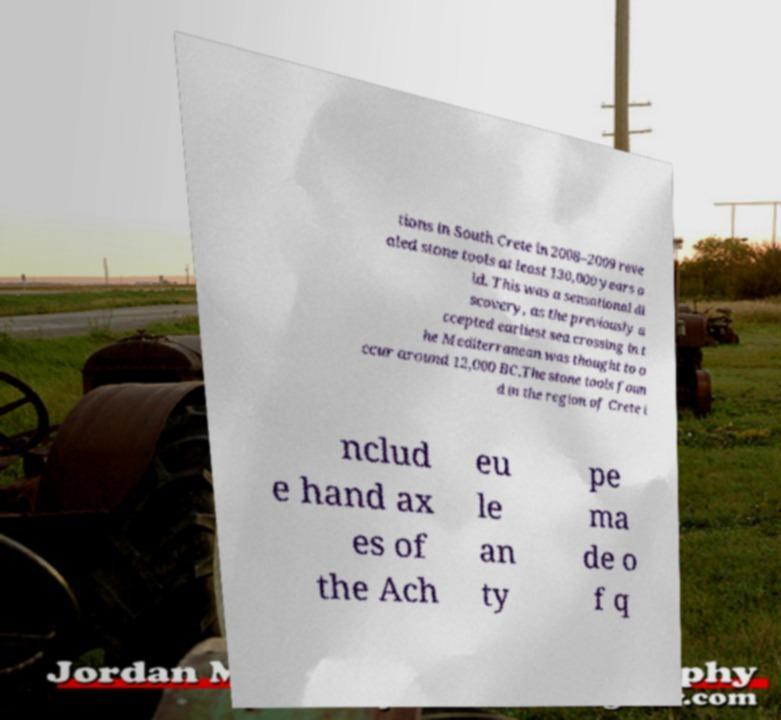Could you extract and type out the text from this image? tions in South Crete in 2008–2009 reve aled stone tools at least 130,000 years o ld. This was a sensational di scovery, as the previously a ccepted earliest sea crossing in t he Mediterranean was thought to o ccur around 12,000 BC.The stone tools foun d in the region of Crete i nclud e hand ax es of the Ach eu le an ty pe ma de o f q 